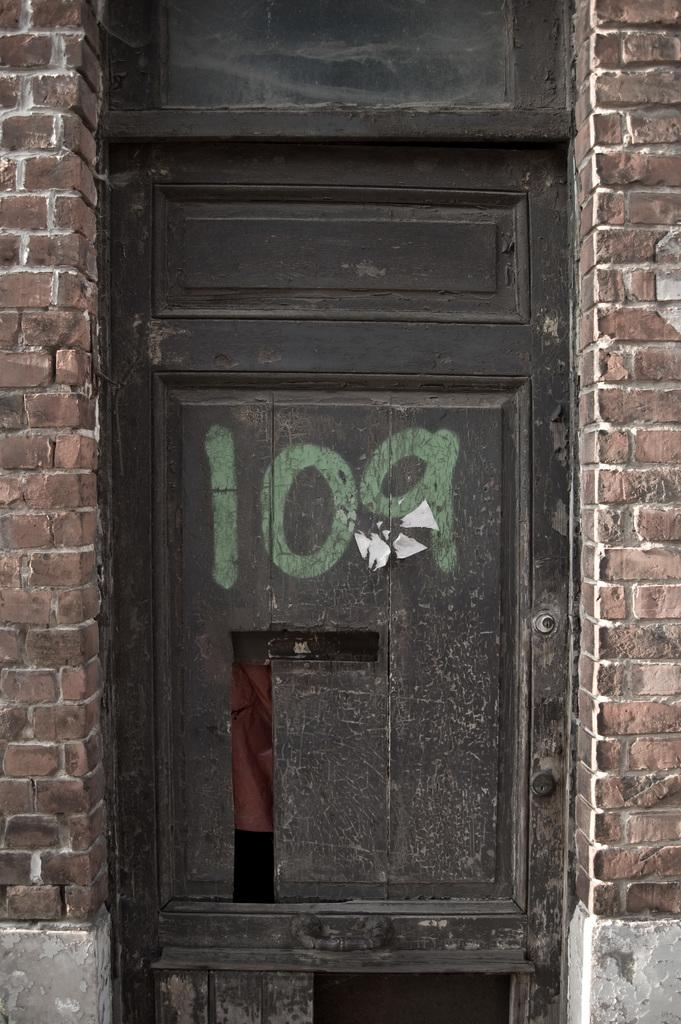What is the main subject of the image? The main subject of the image is a wooden door with a number in the middle. What type of material is used for the walls in the image? The walls in the image are made of brick. Where are the brick walls located in the image? The brick walls are in the left and right corners of the image. How many deer can be seen grazing near the door in the image? There are no deer present in the image; it features a wooden door with a number and brick walls. What type of insect is crawling on the door in the image? There are no insects visible on the door in the image. 